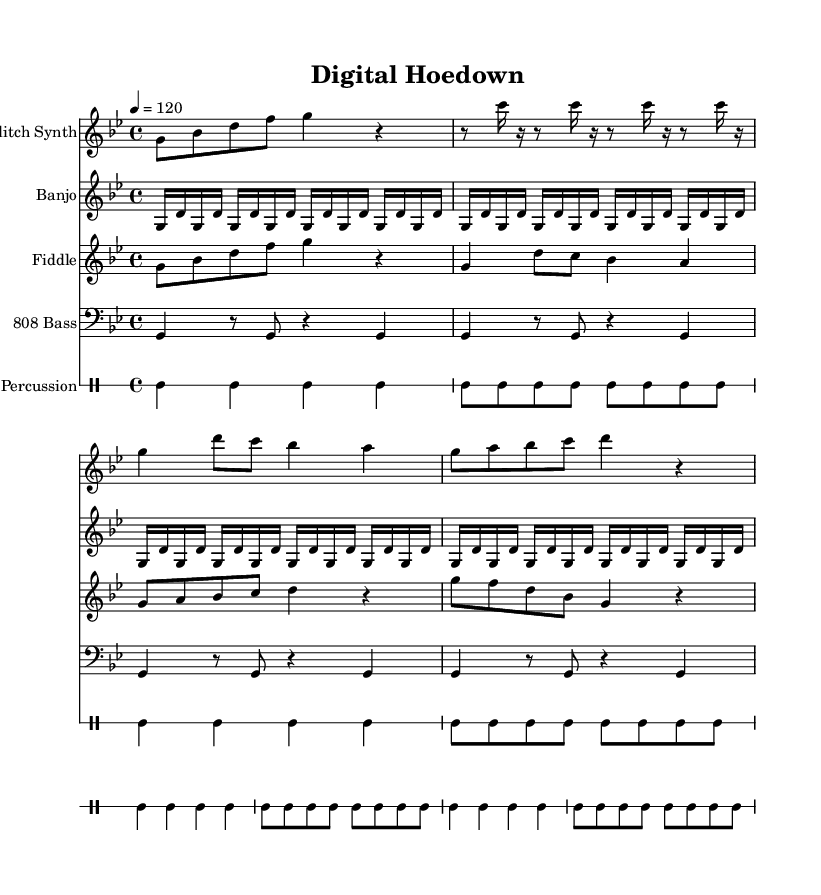What is the key signature of the piece? The key signature indicates B flat and E flat, which is characteristic of G minor.
Answer: G minor What is the time signature of the piece? The time signature appears at the beginning of the score and is shown as four beats in a measure, indicated by the numbers 4/4.
Answer: 4/4 What is the tempo marking provided in the score? The tempo marking is specified at the beginning of the score, showing a speed of 120 beats per minute, indicated by the number 4 followed by an equals sign and the number 120.
Answer: 120 How many measures does the Glitch Synth part contain? The Glitch Synth part consists of four measures as indicated by the number of distinct groupings separated by vertical lines.
Answer: 4 Which traditional folk instrument appears in the score? The score includes a section for the Banjo, which is labeled as a traditional folk instrument in one of the staves.
Answer: Banjo How is the rhythm of the drums structured in the piece? The drum rhythm is indicated using the drummode notation, which shows a repeating pattern of eighth notes across four measures, confirming uniformity in beat placement.
Answer: Repeating eighth notes What unique element does this piece incorporate that differentiates it from typical folk music? This composition uniquely fuses glitch-hop elements with folk instruments, merging electronic sounds with acoustic textures.
Answer: Glitch-hop fusion 